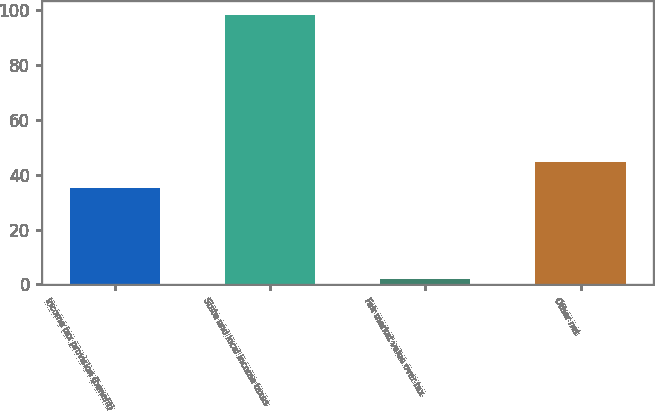Convert chart to OTSL. <chart><loc_0><loc_0><loc_500><loc_500><bar_chart><fcel>Income tax provision (benefit)<fcel>State and local income taxes<fcel>Fair market value over tax<fcel>Other net<nl><fcel>35<fcel>98.3<fcel>2.04<fcel>44.63<nl></chart> 